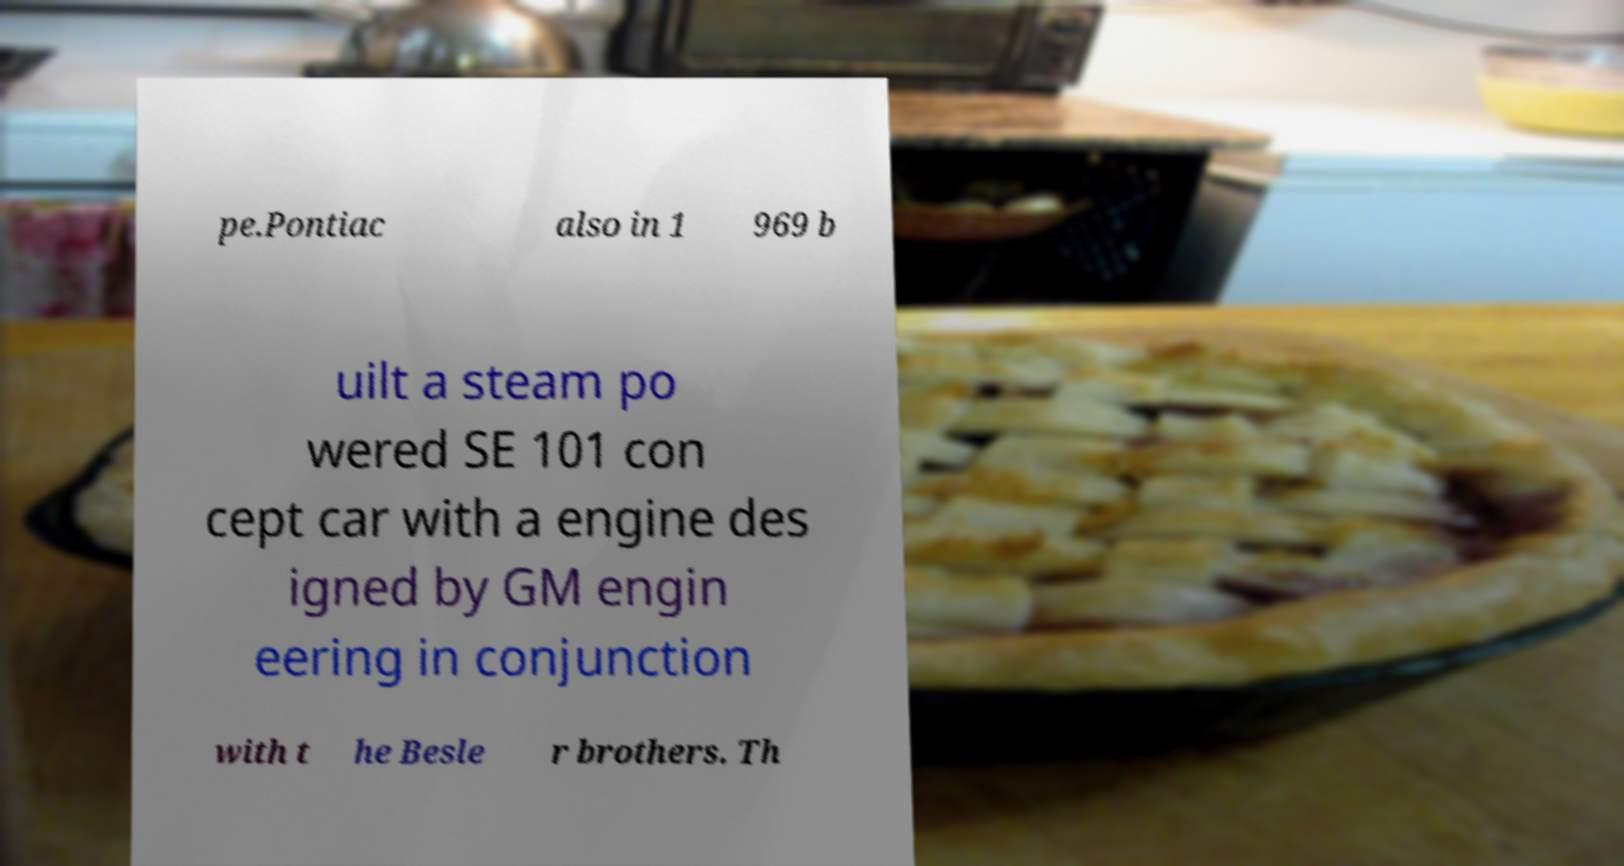I need the written content from this picture converted into text. Can you do that? pe.Pontiac also in 1 969 b uilt a steam po wered SE 101 con cept car with a engine des igned by GM engin eering in conjunction with t he Besle r brothers. Th 